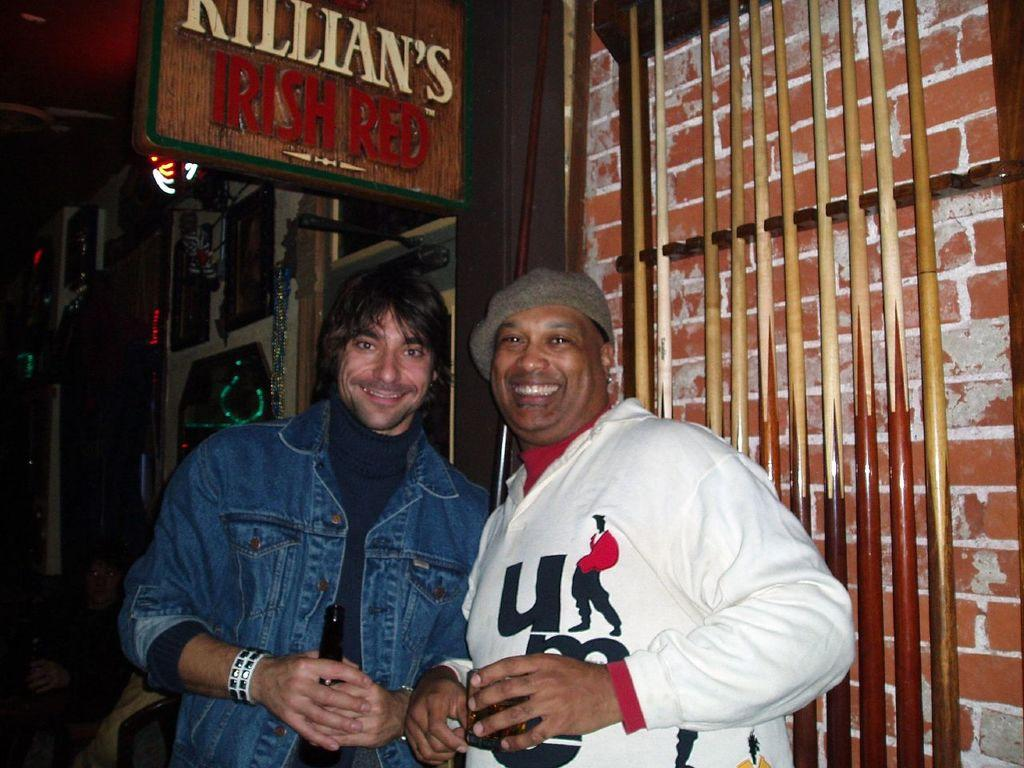Provide a one-sentence caption for the provided image. Two friends pose beneath a Killian's Irish Red sign. 